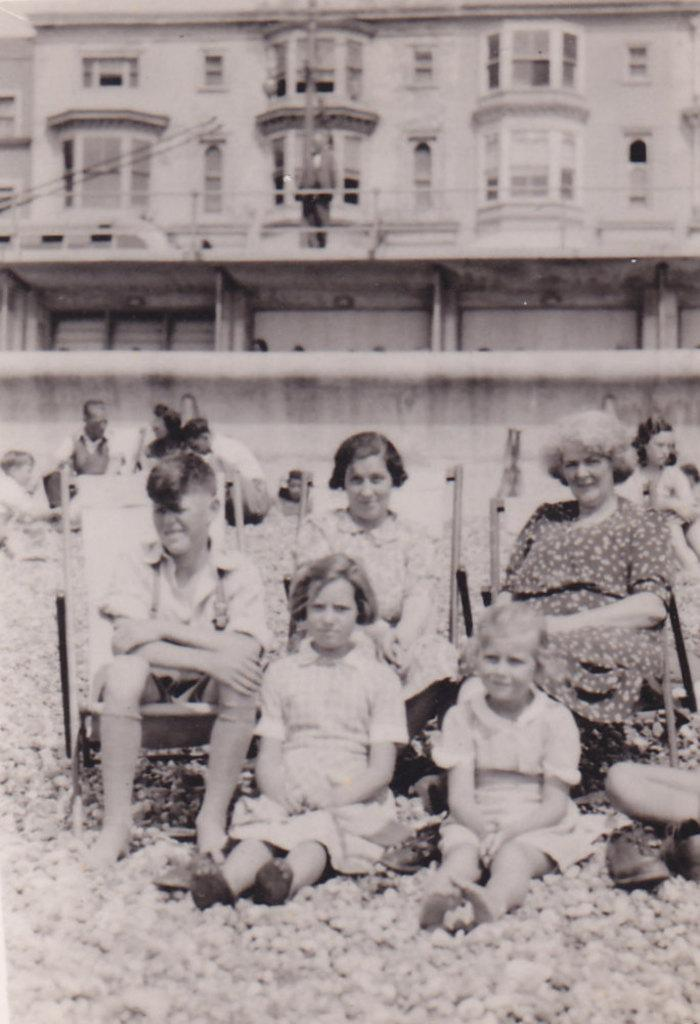What is the color scheme of the image? The image is black and white. What are the people in the image doing? There are people sitting on chairs and on the ground. What can be seen in the background of the image? There is a building in the background of the image. What is the closest structure to the people in the image? There is a wall in the image. How many stars can be seen in the image? There are no stars visible in the image, as it is a black and white image with people sitting on chairs and on the ground, a building in the background, and a wall. What is the suggestion for the people in the image? There is no suggestion provided in the image, as it only shows people sitting on chairs and on the ground, a building in the background, and a wall. 